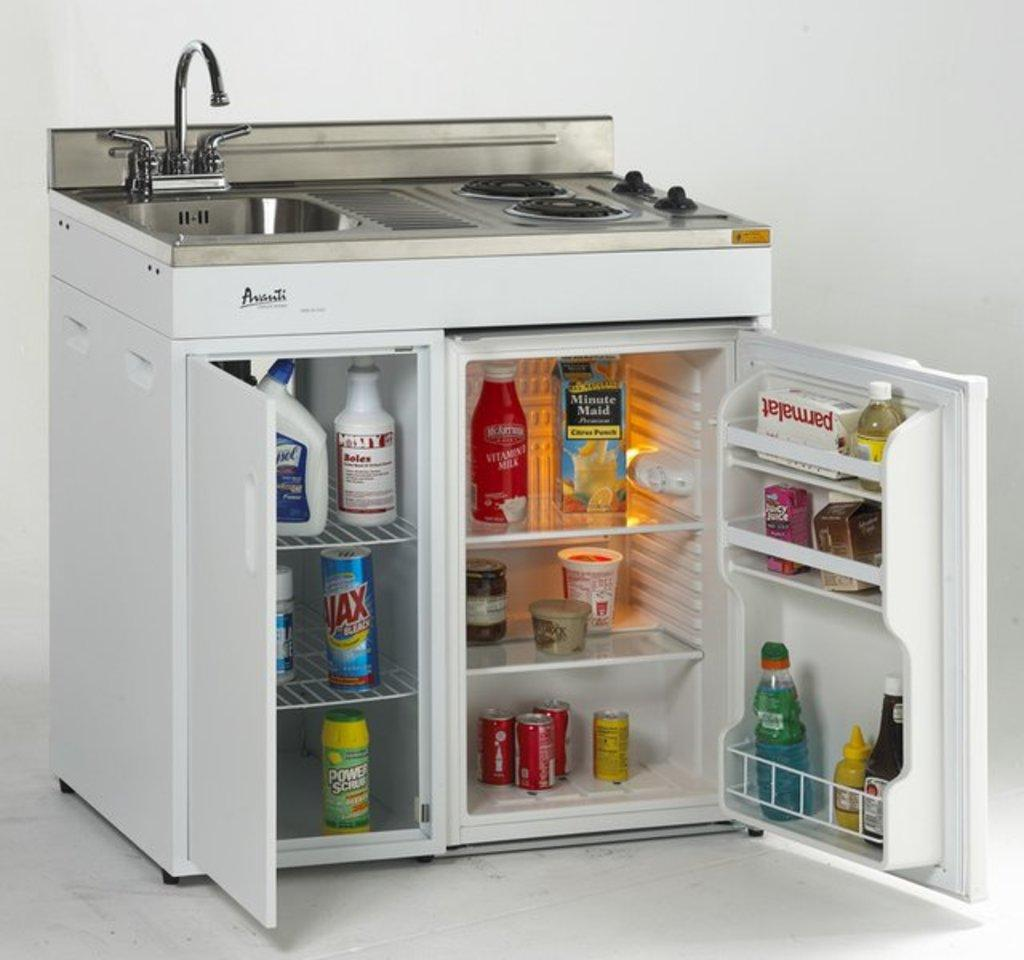What type of appliance is located in the center of the image? There is a mini refrigerator in the center of the image. What is the position of the sink in relation to the mini refrigerator? The sink is at the top of the mini refrigerator. What other kitchen appliance is present in the image? There is a stove in the image. Where is the stove located in relation to the mini refrigerator? The stove is at the top of the mini refrigerator. What type of prose can be found in the image? There is no prose present in the image; it is a picture of a mini refrigerator, sink, and stove. 